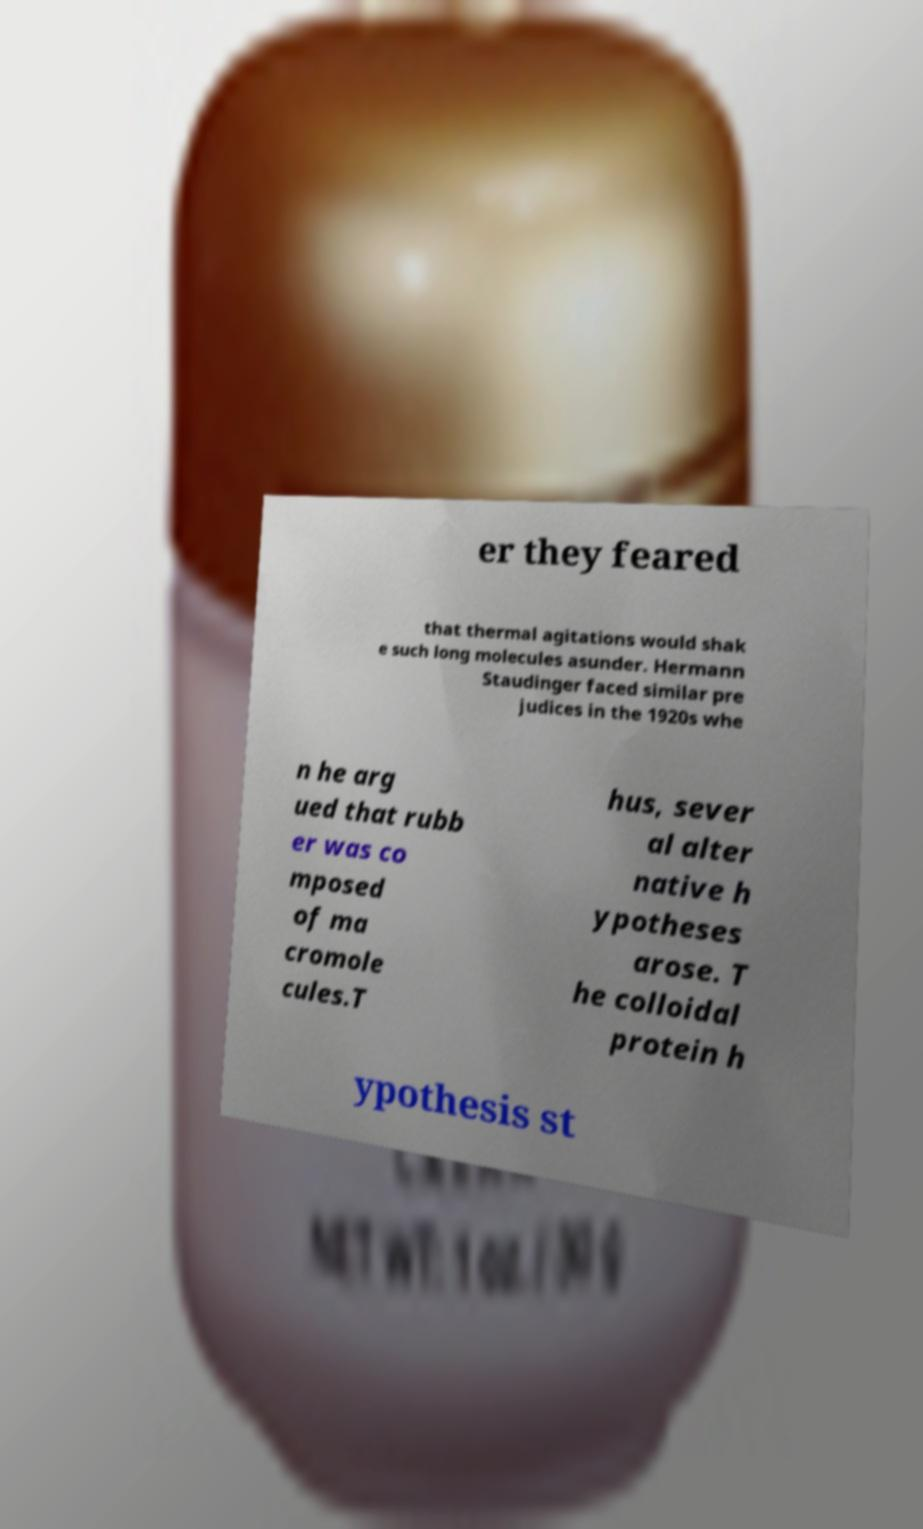There's text embedded in this image that I need extracted. Can you transcribe it verbatim? er they feared that thermal agitations would shak e such long molecules asunder. Hermann Staudinger faced similar pre judices in the 1920s whe n he arg ued that rubb er was co mposed of ma cromole cules.T hus, sever al alter native h ypotheses arose. T he colloidal protein h ypothesis st 